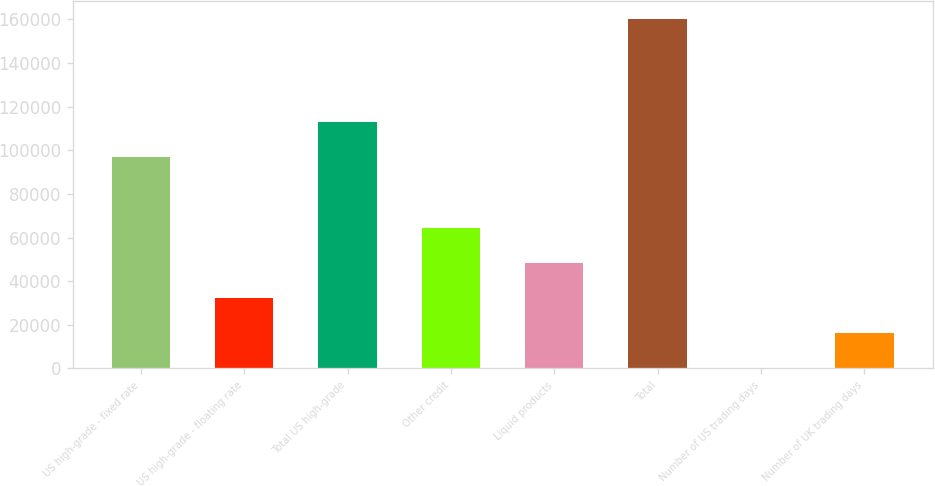Convert chart to OTSL. <chart><loc_0><loc_0><loc_500><loc_500><bar_chart><fcel>US high-grade - fixed rate<fcel>US high-grade - floating rate<fcel>Total US high-grade<fcel>Other credit<fcel>Liquid products<fcel>Total<fcel>Number of US trading days<fcel>Number of UK trading days<nl><fcel>96736<fcel>32120<fcel>112766<fcel>64180<fcel>48150<fcel>160360<fcel>60<fcel>16090<nl></chart> 